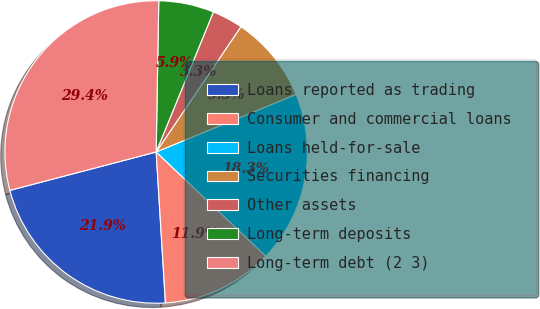<chart> <loc_0><loc_0><loc_500><loc_500><pie_chart><fcel>Loans reported as trading<fcel>Consumer and commercial loans<fcel>Loans held-for-sale<fcel>Securities financing<fcel>Other assets<fcel>Long-term deposits<fcel>Long-term debt (2 3)<nl><fcel>21.89%<fcel>11.93%<fcel>18.31%<fcel>9.32%<fcel>3.29%<fcel>5.9%<fcel>29.36%<nl></chart> 